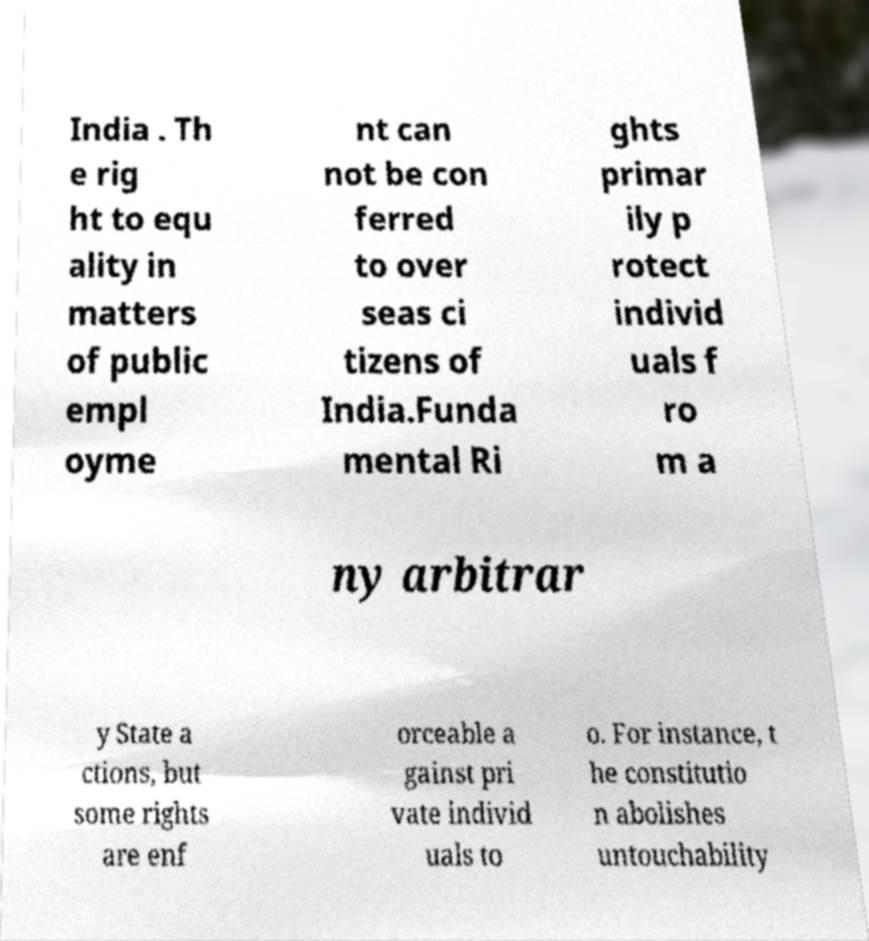What messages or text are displayed in this image? I need them in a readable, typed format. India . Th e rig ht to equ ality in matters of public empl oyme nt can not be con ferred to over seas ci tizens of India.Funda mental Ri ghts primar ily p rotect individ uals f ro m a ny arbitrar y State a ctions, but some rights are enf orceable a gainst pri vate individ uals to o. For instance, t he constitutio n abolishes untouchability 